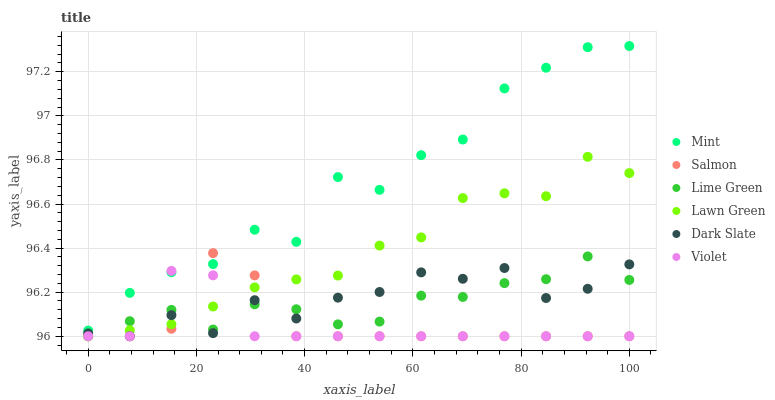Does Violet have the minimum area under the curve?
Answer yes or no. Yes. Does Mint have the maximum area under the curve?
Answer yes or no. Yes. Does Lime Green have the minimum area under the curve?
Answer yes or no. No. Does Lime Green have the maximum area under the curve?
Answer yes or no. No. Is Lawn Green the smoothest?
Answer yes or no. Yes. Is Mint the roughest?
Answer yes or no. Yes. Is Lime Green the smoothest?
Answer yes or no. No. Is Lime Green the roughest?
Answer yes or no. No. Does Lawn Green have the lowest value?
Answer yes or no. Yes. Does Mint have the lowest value?
Answer yes or no. No. Does Mint have the highest value?
Answer yes or no. Yes. Does Lime Green have the highest value?
Answer yes or no. No. Is Lime Green less than Mint?
Answer yes or no. Yes. Is Mint greater than Dark Slate?
Answer yes or no. Yes. Does Violet intersect Mint?
Answer yes or no. Yes. Is Violet less than Mint?
Answer yes or no. No. Is Violet greater than Mint?
Answer yes or no. No. Does Lime Green intersect Mint?
Answer yes or no. No. 